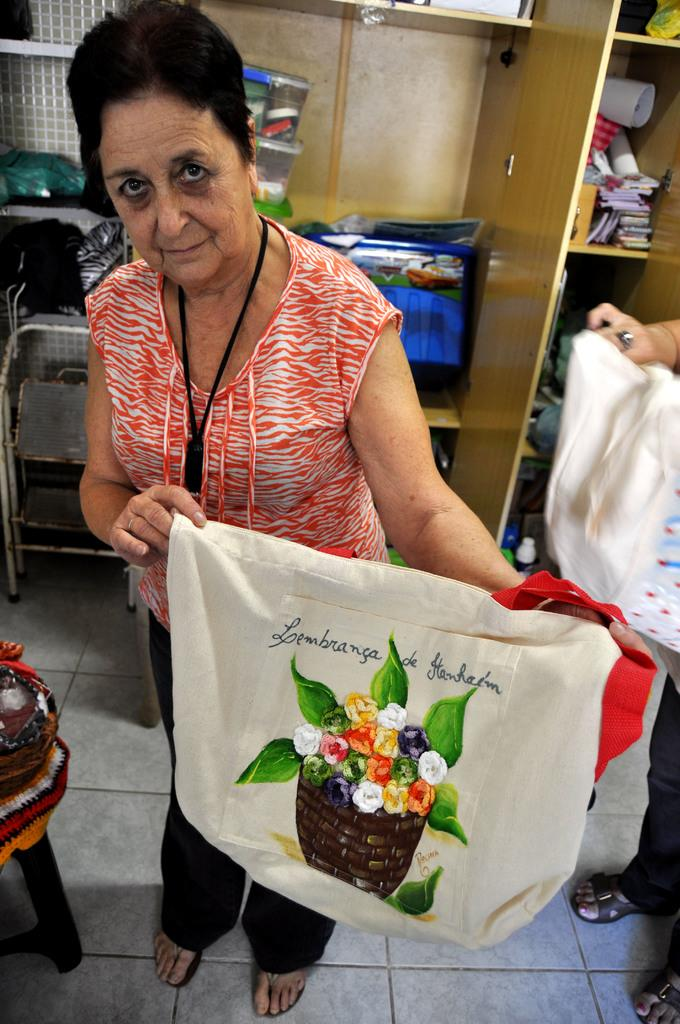What is the woman in the image doing? The woman is standing in the image and holding a bag in her hands. What can be seen on the bag the woman is holding? The bag has a painting on it. What is present in the image besides the woman and the bag? There is a rack in the image, and there are objects in the rack. How many cents can be seen on the wall in the image? There is no mention of cents or a wall in the image. The image features a woman holding a bag with a painting on it, a rack, and objects in the rack. 